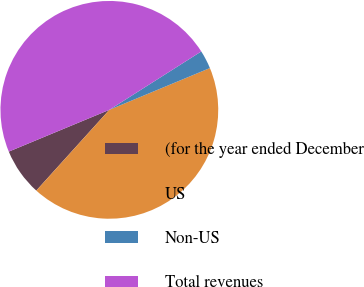Convert chart. <chart><loc_0><loc_0><loc_500><loc_500><pie_chart><fcel>(for the year ended December<fcel>US<fcel>Non-US<fcel>Total revenues<nl><fcel>7.03%<fcel>42.97%<fcel>2.74%<fcel>47.26%<nl></chart> 